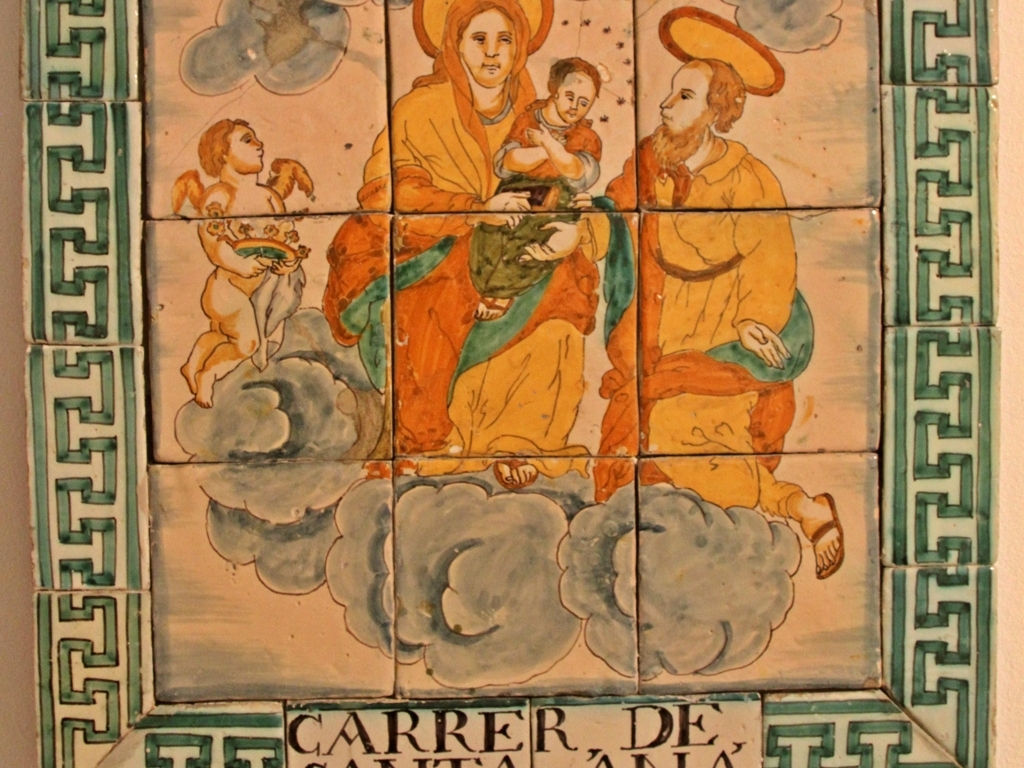Could you describe some of the imagery depicted on these tiles? Certainly! The tiles depict what seems to be religious iconography, with figures that are likely saints, given their halos. The central figure may represent the Virgin Mary holding the infant Jesus, a common motif in Christian art. The surrounding clouds, the angelic figure to the left, and the two saintly figures reinforce the sacred theme. What might the text on the tiles mean? The text 'CARRER DE LA' is visible, which is Catalan or Spanish for 'Street of the.' It's likely part of an address or location name. This could suggest the tiles were once part of a larger installation, possibly serving as a sign for a street or building name associated with religious significance. 